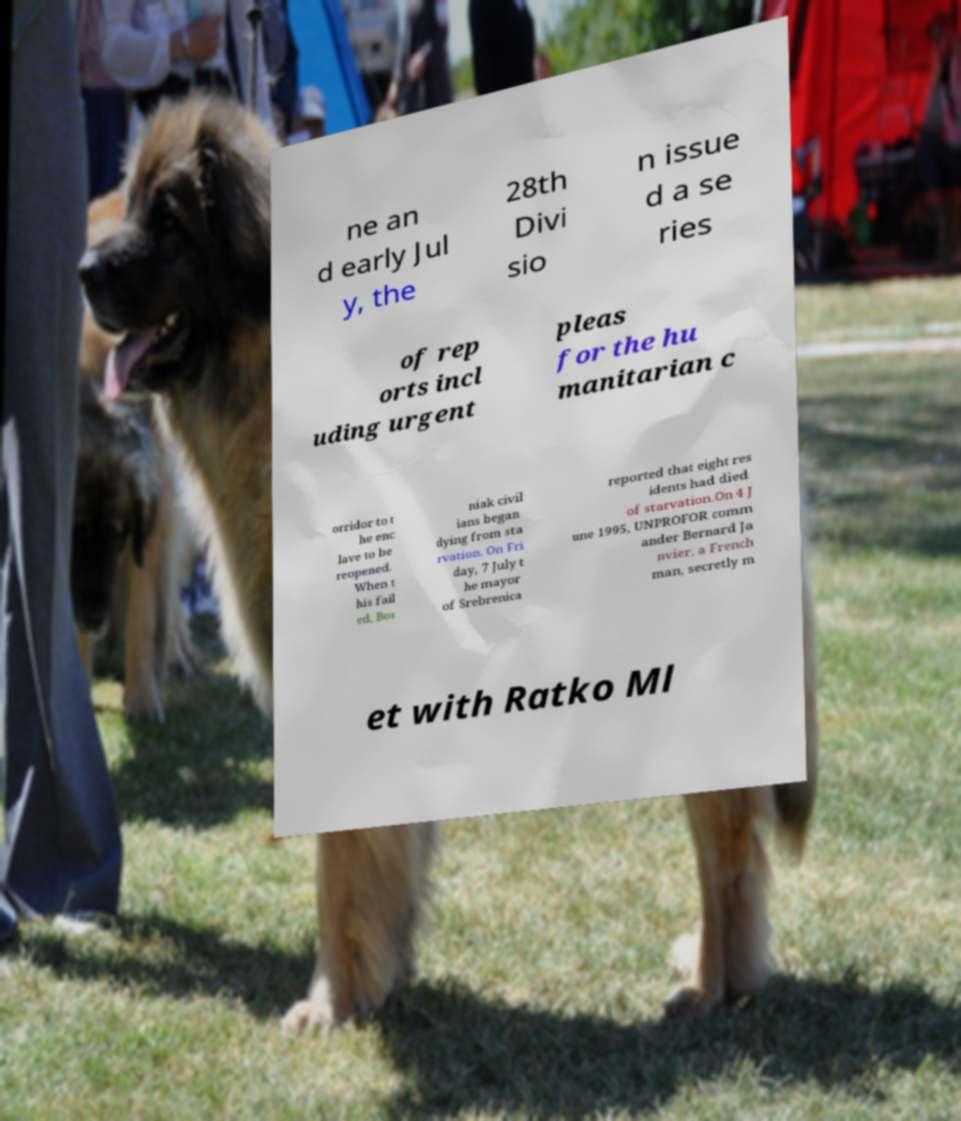What messages or text are displayed in this image? I need them in a readable, typed format. ne an d early Jul y, the 28th Divi sio n issue d a se ries of rep orts incl uding urgent pleas for the hu manitarian c orridor to t he enc lave to be reopened. When t his fail ed, Bos niak civil ians began dying from sta rvation. On Fri day, 7 July t he mayor of Srebrenica reported that eight res idents had died of starvation.On 4 J une 1995, UNPROFOR comm ander Bernard Ja nvier, a French man, secretly m et with Ratko Ml 